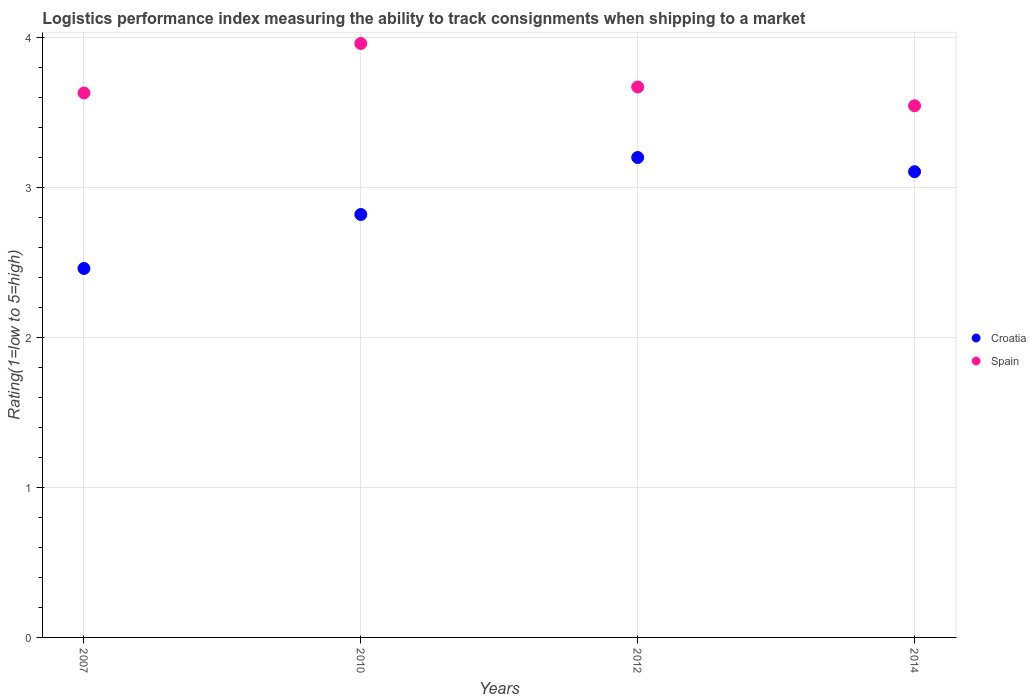Is the number of dotlines equal to the number of legend labels?
Make the answer very short. Yes. What is the Logistic performance index in Croatia in 2007?
Ensure brevity in your answer.  2.46. Across all years, what is the minimum Logistic performance index in Spain?
Make the answer very short. 3.54. In which year was the Logistic performance index in Spain maximum?
Provide a succinct answer. 2010. What is the total Logistic performance index in Croatia in the graph?
Ensure brevity in your answer.  11.59. What is the difference between the Logistic performance index in Croatia in 2007 and that in 2014?
Your response must be concise. -0.65. What is the difference between the Logistic performance index in Spain in 2012 and the Logistic performance index in Croatia in 2010?
Provide a short and direct response. 0.85. What is the average Logistic performance index in Spain per year?
Offer a terse response. 3.7. In the year 2010, what is the difference between the Logistic performance index in Spain and Logistic performance index in Croatia?
Your response must be concise. 1.14. What is the ratio of the Logistic performance index in Croatia in 2010 to that in 2012?
Your answer should be very brief. 0.88. Is the Logistic performance index in Spain in 2007 less than that in 2012?
Offer a terse response. Yes. What is the difference between the highest and the second highest Logistic performance index in Croatia?
Give a very brief answer. 0.09. What is the difference between the highest and the lowest Logistic performance index in Croatia?
Keep it short and to the point. 0.74. In how many years, is the Logistic performance index in Croatia greater than the average Logistic performance index in Croatia taken over all years?
Your answer should be compact. 2. How many years are there in the graph?
Make the answer very short. 4. Are the values on the major ticks of Y-axis written in scientific E-notation?
Make the answer very short. No. Does the graph contain grids?
Your answer should be compact. Yes. Where does the legend appear in the graph?
Your response must be concise. Center right. How many legend labels are there?
Provide a succinct answer. 2. What is the title of the graph?
Make the answer very short. Logistics performance index measuring the ability to track consignments when shipping to a market. What is the label or title of the Y-axis?
Provide a succinct answer. Rating(1=low to 5=high). What is the Rating(1=low to 5=high) of Croatia in 2007?
Offer a terse response. 2.46. What is the Rating(1=low to 5=high) of Spain in 2007?
Your answer should be compact. 3.63. What is the Rating(1=low to 5=high) of Croatia in 2010?
Your answer should be compact. 2.82. What is the Rating(1=low to 5=high) in Spain in 2010?
Your response must be concise. 3.96. What is the Rating(1=low to 5=high) of Croatia in 2012?
Offer a terse response. 3.2. What is the Rating(1=low to 5=high) in Spain in 2012?
Keep it short and to the point. 3.67. What is the Rating(1=low to 5=high) in Croatia in 2014?
Offer a terse response. 3.11. What is the Rating(1=low to 5=high) of Spain in 2014?
Make the answer very short. 3.54. Across all years, what is the maximum Rating(1=low to 5=high) of Spain?
Give a very brief answer. 3.96. Across all years, what is the minimum Rating(1=low to 5=high) of Croatia?
Your answer should be compact. 2.46. Across all years, what is the minimum Rating(1=low to 5=high) in Spain?
Provide a succinct answer. 3.54. What is the total Rating(1=low to 5=high) in Croatia in the graph?
Your response must be concise. 11.59. What is the total Rating(1=low to 5=high) of Spain in the graph?
Your answer should be very brief. 14.8. What is the difference between the Rating(1=low to 5=high) in Croatia in 2007 and that in 2010?
Ensure brevity in your answer.  -0.36. What is the difference between the Rating(1=low to 5=high) in Spain in 2007 and that in 2010?
Offer a terse response. -0.33. What is the difference between the Rating(1=low to 5=high) of Croatia in 2007 and that in 2012?
Your answer should be compact. -0.74. What is the difference between the Rating(1=low to 5=high) of Spain in 2007 and that in 2012?
Make the answer very short. -0.04. What is the difference between the Rating(1=low to 5=high) of Croatia in 2007 and that in 2014?
Ensure brevity in your answer.  -0.65. What is the difference between the Rating(1=low to 5=high) in Spain in 2007 and that in 2014?
Offer a terse response. 0.09. What is the difference between the Rating(1=low to 5=high) of Croatia in 2010 and that in 2012?
Give a very brief answer. -0.38. What is the difference between the Rating(1=low to 5=high) in Spain in 2010 and that in 2012?
Ensure brevity in your answer.  0.29. What is the difference between the Rating(1=low to 5=high) of Croatia in 2010 and that in 2014?
Keep it short and to the point. -0.29. What is the difference between the Rating(1=low to 5=high) of Spain in 2010 and that in 2014?
Your answer should be compact. 0.42. What is the difference between the Rating(1=low to 5=high) of Croatia in 2012 and that in 2014?
Your response must be concise. 0.09. What is the difference between the Rating(1=low to 5=high) of Spain in 2012 and that in 2014?
Give a very brief answer. 0.13. What is the difference between the Rating(1=low to 5=high) of Croatia in 2007 and the Rating(1=low to 5=high) of Spain in 2012?
Ensure brevity in your answer.  -1.21. What is the difference between the Rating(1=low to 5=high) of Croatia in 2007 and the Rating(1=low to 5=high) of Spain in 2014?
Make the answer very short. -1.08. What is the difference between the Rating(1=low to 5=high) in Croatia in 2010 and the Rating(1=low to 5=high) in Spain in 2012?
Your answer should be compact. -0.85. What is the difference between the Rating(1=low to 5=high) of Croatia in 2010 and the Rating(1=low to 5=high) of Spain in 2014?
Give a very brief answer. -0.72. What is the difference between the Rating(1=low to 5=high) of Croatia in 2012 and the Rating(1=low to 5=high) of Spain in 2014?
Make the answer very short. -0.34. What is the average Rating(1=low to 5=high) in Croatia per year?
Make the answer very short. 2.9. What is the average Rating(1=low to 5=high) of Spain per year?
Your answer should be very brief. 3.7. In the year 2007, what is the difference between the Rating(1=low to 5=high) of Croatia and Rating(1=low to 5=high) of Spain?
Your answer should be compact. -1.17. In the year 2010, what is the difference between the Rating(1=low to 5=high) of Croatia and Rating(1=low to 5=high) of Spain?
Make the answer very short. -1.14. In the year 2012, what is the difference between the Rating(1=low to 5=high) of Croatia and Rating(1=low to 5=high) of Spain?
Ensure brevity in your answer.  -0.47. In the year 2014, what is the difference between the Rating(1=low to 5=high) in Croatia and Rating(1=low to 5=high) in Spain?
Keep it short and to the point. -0.44. What is the ratio of the Rating(1=low to 5=high) of Croatia in 2007 to that in 2010?
Give a very brief answer. 0.87. What is the ratio of the Rating(1=low to 5=high) of Spain in 2007 to that in 2010?
Ensure brevity in your answer.  0.92. What is the ratio of the Rating(1=low to 5=high) in Croatia in 2007 to that in 2012?
Give a very brief answer. 0.77. What is the ratio of the Rating(1=low to 5=high) in Croatia in 2007 to that in 2014?
Your answer should be compact. 0.79. What is the ratio of the Rating(1=low to 5=high) of Spain in 2007 to that in 2014?
Keep it short and to the point. 1.02. What is the ratio of the Rating(1=low to 5=high) of Croatia in 2010 to that in 2012?
Provide a short and direct response. 0.88. What is the ratio of the Rating(1=low to 5=high) in Spain in 2010 to that in 2012?
Offer a terse response. 1.08. What is the ratio of the Rating(1=low to 5=high) of Croatia in 2010 to that in 2014?
Keep it short and to the point. 0.91. What is the ratio of the Rating(1=low to 5=high) in Spain in 2010 to that in 2014?
Your answer should be compact. 1.12. What is the ratio of the Rating(1=low to 5=high) of Croatia in 2012 to that in 2014?
Provide a short and direct response. 1.03. What is the ratio of the Rating(1=low to 5=high) in Spain in 2012 to that in 2014?
Your response must be concise. 1.04. What is the difference between the highest and the second highest Rating(1=low to 5=high) of Croatia?
Your answer should be very brief. 0.09. What is the difference between the highest and the second highest Rating(1=low to 5=high) of Spain?
Your answer should be very brief. 0.29. What is the difference between the highest and the lowest Rating(1=low to 5=high) of Croatia?
Make the answer very short. 0.74. What is the difference between the highest and the lowest Rating(1=low to 5=high) in Spain?
Make the answer very short. 0.42. 